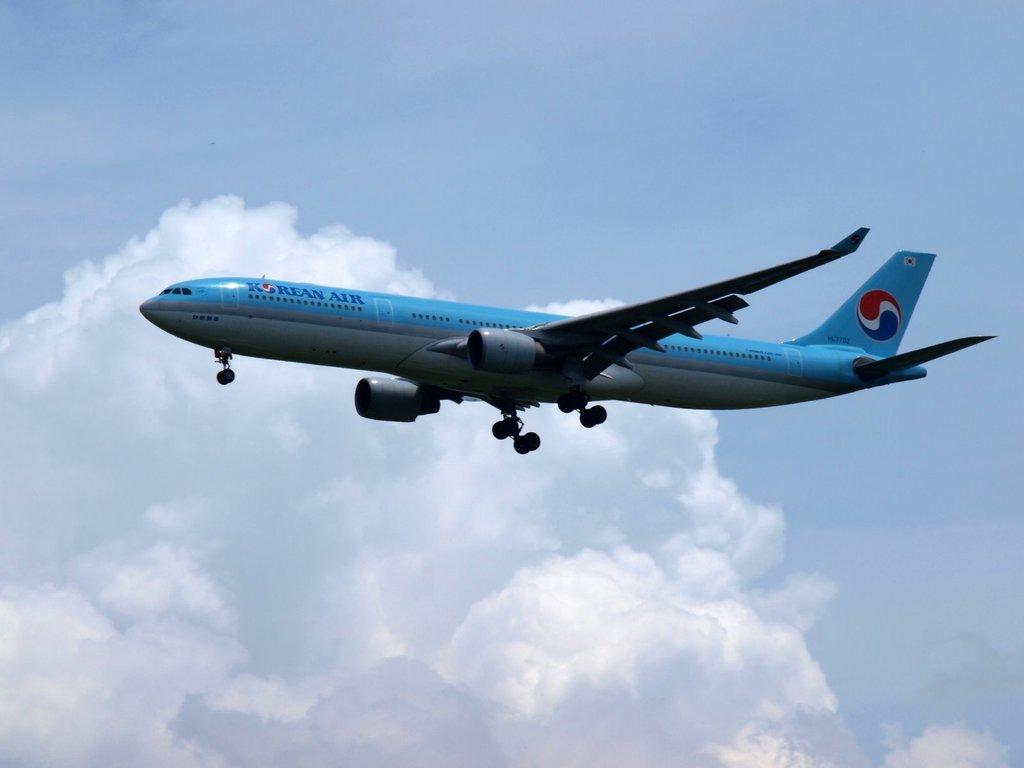What airline is this plane from?
Offer a terse response. Korean air. 